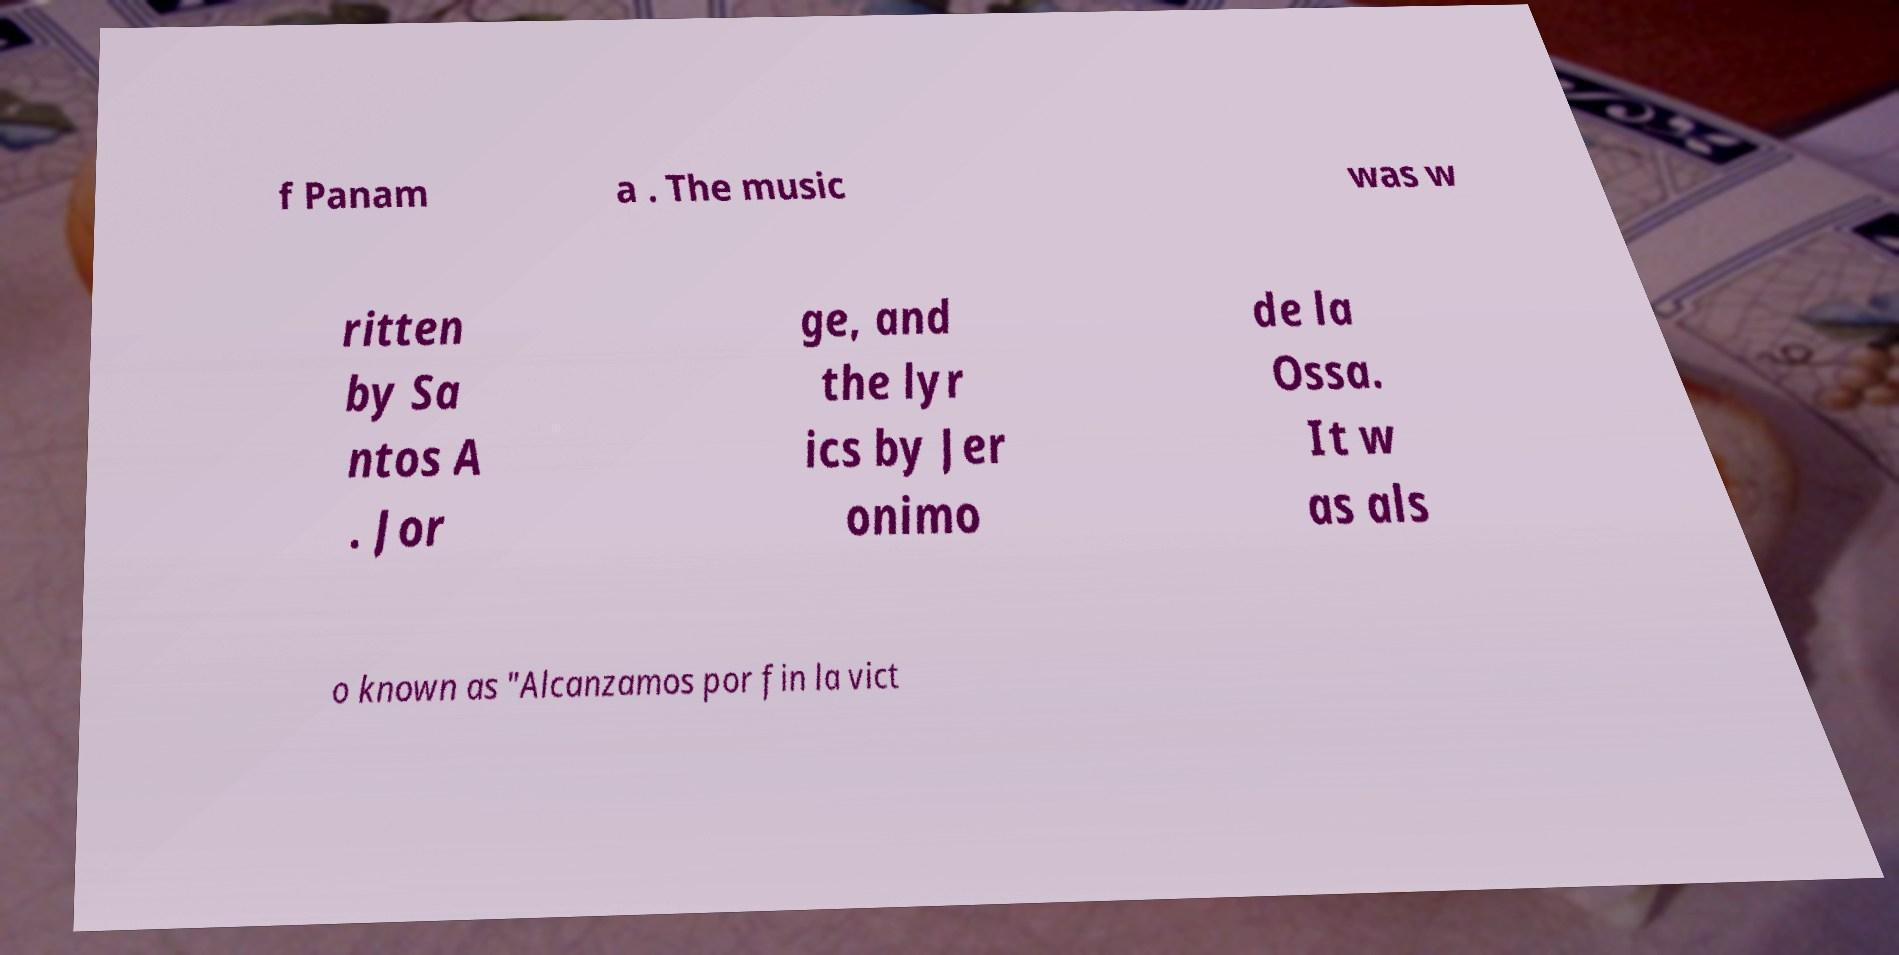Please read and relay the text visible in this image. What does it say? f Panam a . The music was w ritten by Sa ntos A . Jor ge, and the lyr ics by Jer onimo de la Ossa. It w as als o known as "Alcanzamos por fin la vict 